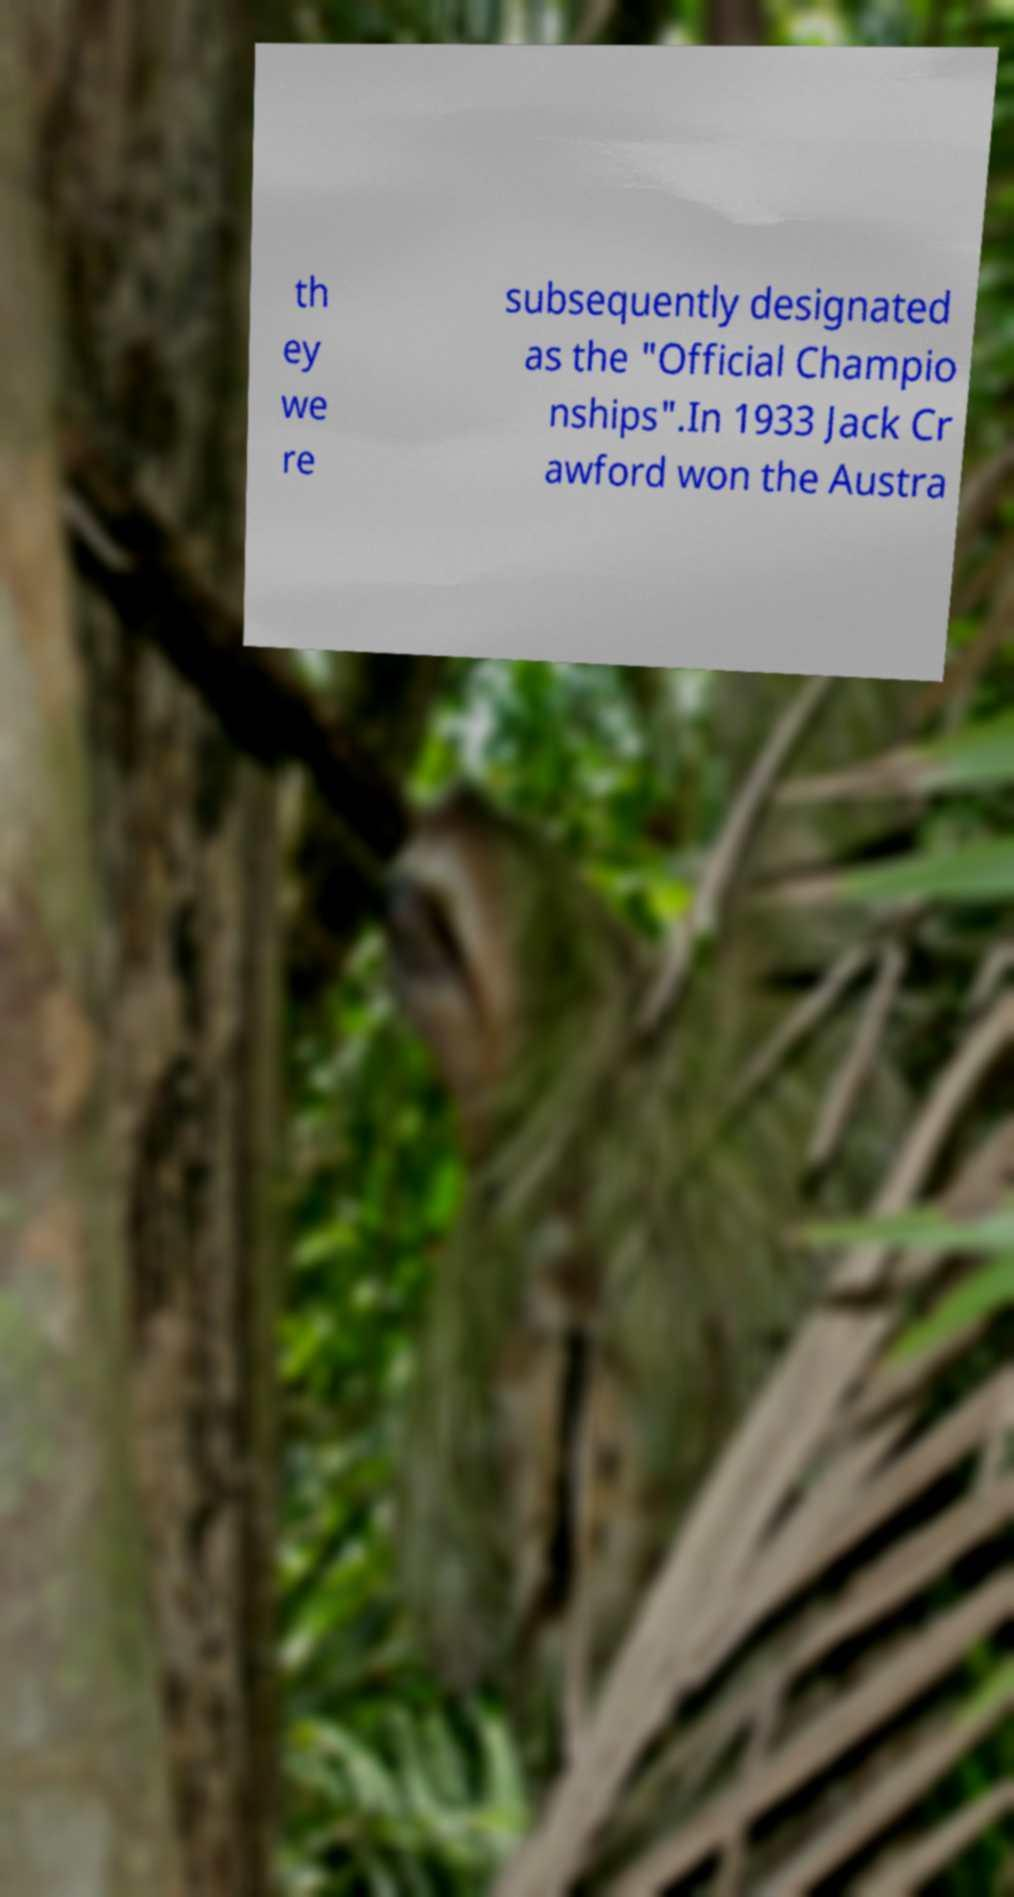For documentation purposes, I need the text within this image transcribed. Could you provide that? th ey we re subsequently designated as the "Official Champio nships".In 1933 Jack Cr awford won the Austra 